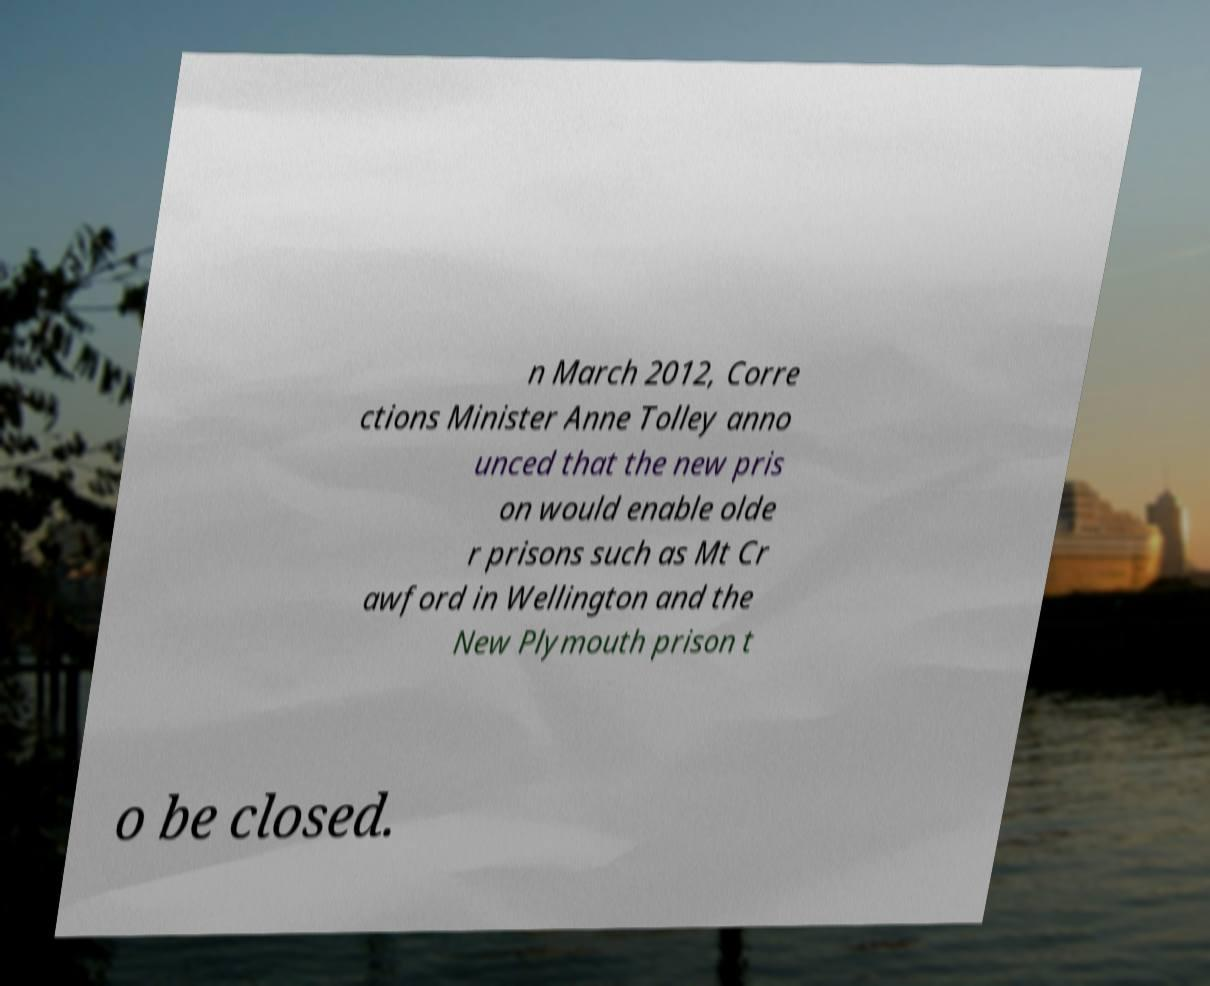For documentation purposes, I need the text within this image transcribed. Could you provide that? n March 2012, Corre ctions Minister Anne Tolley anno unced that the new pris on would enable olde r prisons such as Mt Cr awford in Wellington and the New Plymouth prison t o be closed. 